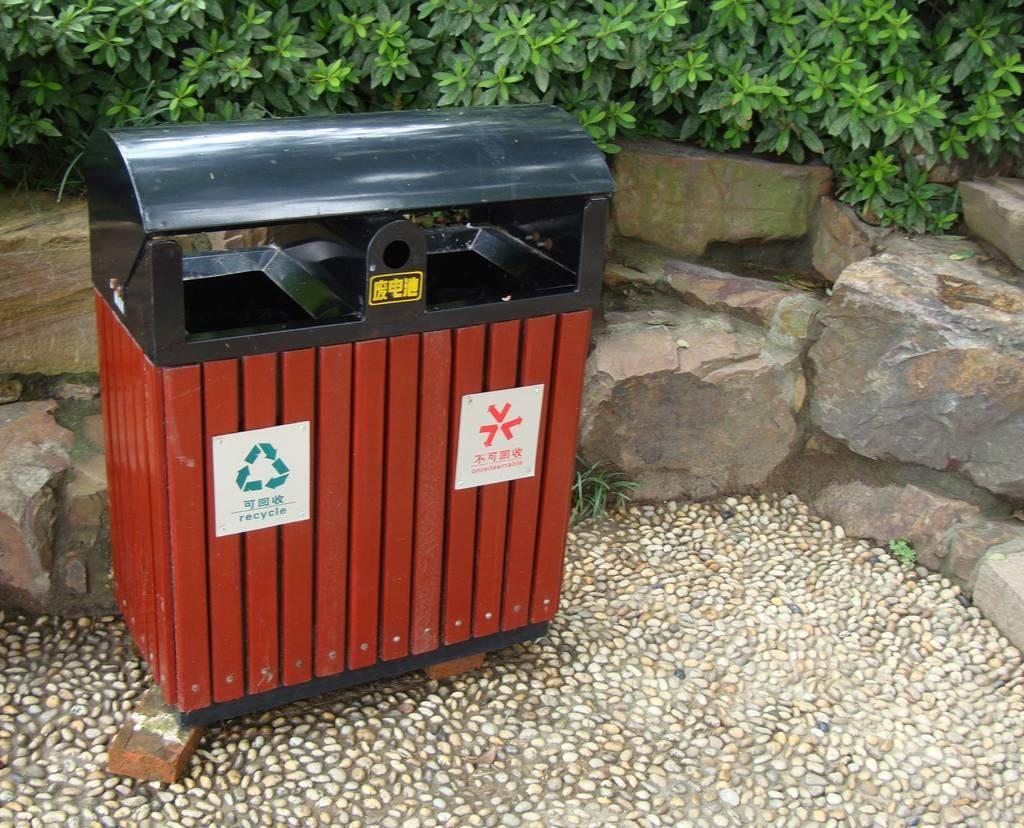<image>
Describe the image concisely. A garbage and recycle bin  with a cigarette putter outer on top. 